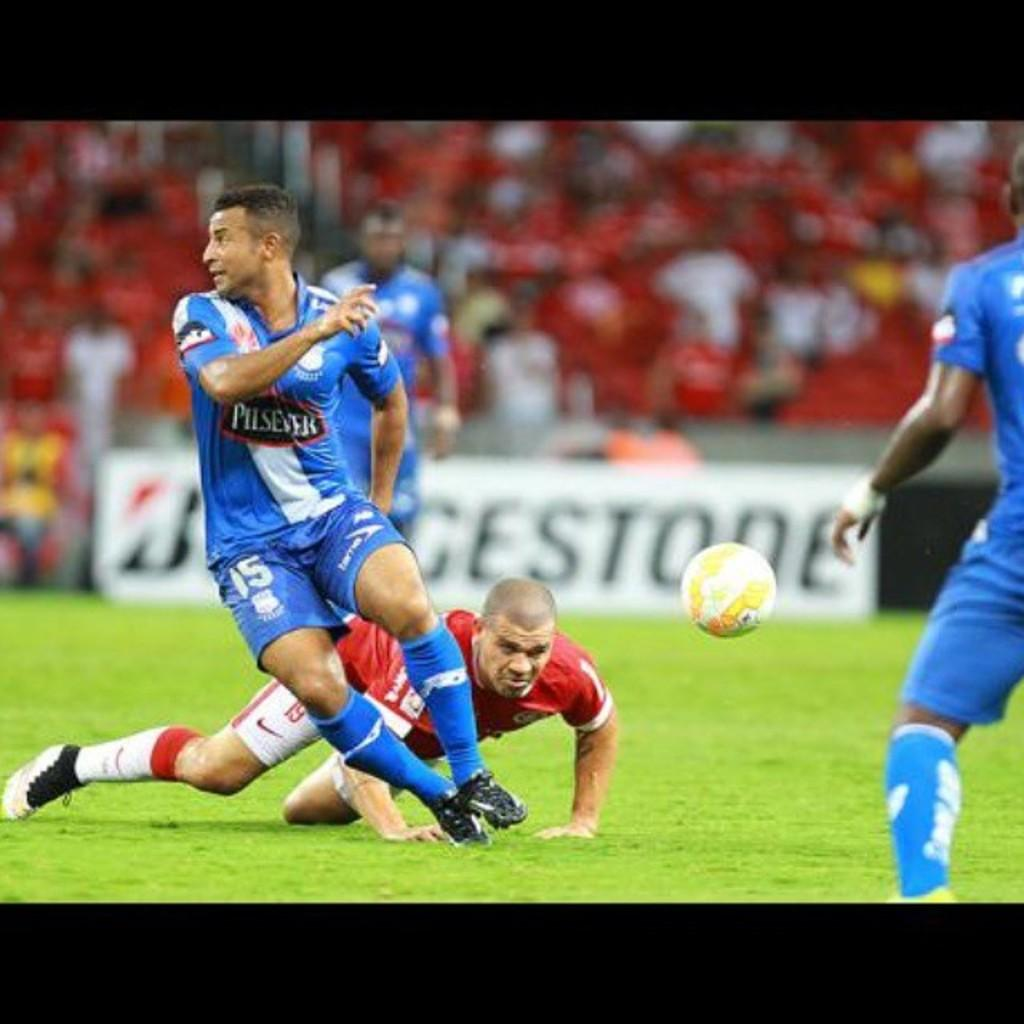<image>
Give a short and clear explanation of the subsequent image. A bunch of athletes playing on a field sponsored by Bridgestone. 